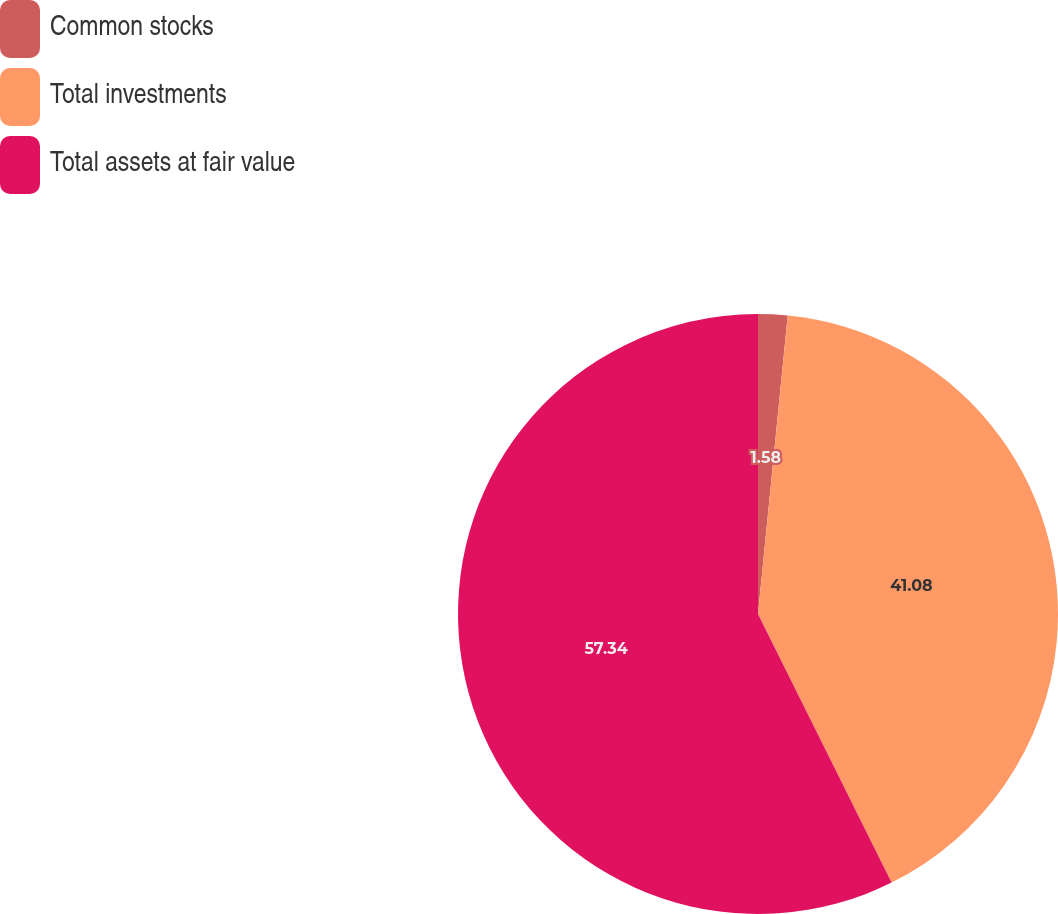<chart> <loc_0><loc_0><loc_500><loc_500><pie_chart><fcel>Common stocks<fcel>Total investments<fcel>Total assets at fair value<nl><fcel>1.58%<fcel>41.08%<fcel>57.35%<nl></chart> 